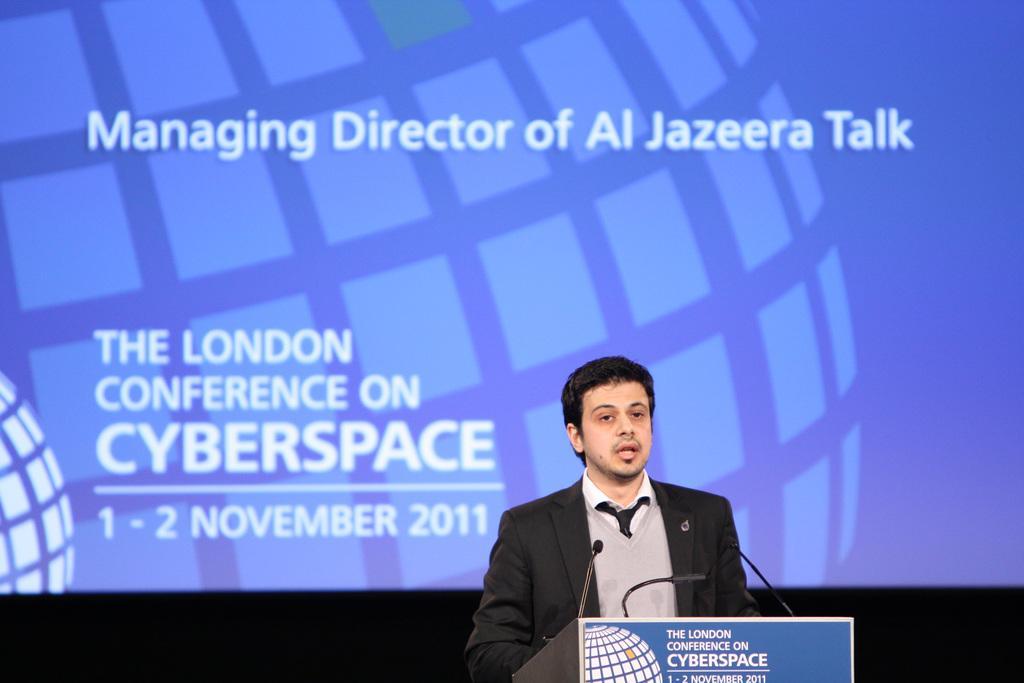Can you describe this image briefly? In this image we can see the podium, one man standing near the podium and talking. There are three microphones attached to the podium, some text, numbers and logo on the podium. There is one big blue screen in the background with text, numbers and logo. In the background bottom of the image is dark. 